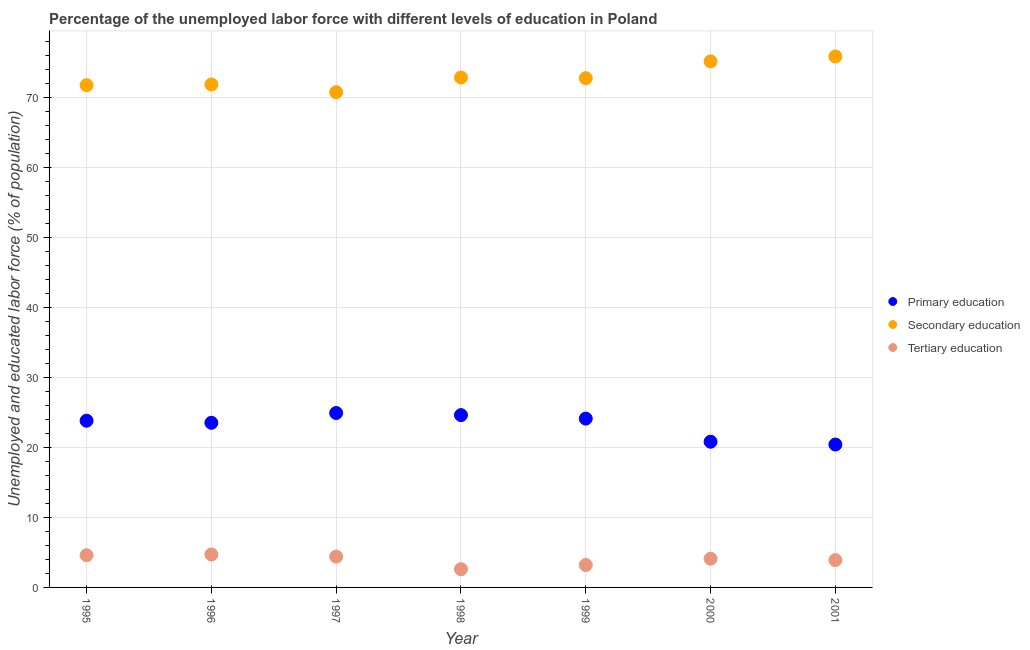Is the number of dotlines equal to the number of legend labels?
Your answer should be compact. Yes. What is the percentage of labor force who received primary education in 2000?
Your answer should be very brief. 20.8. Across all years, what is the maximum percentage of labor force who received primary education?
Provide a short and direct response. 24.9. Across all years, what is the minimum percentage of labor force who received tertiary education?
Give a very brief answer. 2.6. In which year was the percentage of labor force who received tertiary education minimum?
Your answer should be compact. 1998. What is the total percentage of labor force who received secondary education in the graph?
Provide a succinct answer. 510.6. What is the difference between the percentage of labor force who received primary education in 1996 and that in 2000?
Give a very brief answer. 2.7. What is the difference between the percentage of labor force who received tertiary education in 1996 and the percentage of labor force who received primary education in 1995?
Ensure brevity in your answer.  -19.1. What is the average percentage of labor force who received tertiary education per year?
Your response must be concise. 3.93. In the year 2001, what is the difference between the percentage of labor force who received secondary education and percentage of labor force who received tertiary education?
Offer a terse response. 71.9. In how many years, is the percentage of labor force who received tertiary education greater than 68 %?
Your answer should be compact. 0. What is the ratio of the percentage of labor force who received secondary education in 1997 to that in 2001?
Provide a short and direct response. 0.93. Is the percentage of labor force who received secondary education in 1996 less than that in 1999?
Your answer should be very brief. Yes. Is the difference between the percentage of labor force who received primary education in 1998 and 1999 greater than the difference between the percentage of labor force who received secondary education in 1998 and 1999?
Give a very brief answer. Yes. What is the difference between the highest and the second highest percentage of labor force who received secondary education?
Make the answer very short. 0.7. What is the difference between the highest and the lowest percentage of labor force who received tertiary education?
Your answer should be very brief. 2.1. In how many years, is the percentage of labor force who received secondary education greater than the average percentage of labor force who received secondary education taken over all years?
Your answer should be very brief. 2. Does the percentage of labor force who received tertiary education monotonically increase over the years?
Ensure brevity in your answer.  No. Is the percentage of labor force who received primary education strictly less than the percentage of labor force who received secondary education over the years?
Make the answer very short. Yes. How many dotlines are there?
Your answer should be very brief. 3. What is the difference between two consecutive major ticks on the Y-axis?
Make the answer very short. 10. Are the values on the major ticks of Y-axis written in scientific E-notation?
Give a very brief answer. No. Where does the legend appear in the graph?
Your answer should be very brief. Center right. What is the title of the graph?
Ensure brevity in your answer.  Percentage of the unemployed labor force with different levels of education in Poland. What is the label or title of the Y-axis?
Offer a terse response. Unemployed and educated labor force (% of population). What is the Unemployed and educated labor force (% of population) of Primary education in 1995?
Give a very brief answer. 23.8. What is the Unemployed and educated labor force (% of population) of Secondary education in 1995?
Keep it short and to the point. 71.7. What is the Unemployed and educated labor force (% of population) of Tertiary education in 1995?
Provide a succinct answer. 4.6. What is the Unemployed and educated labor force (% of population) of Secondary education in 1996?
Offer a very short reply. 71.8. What is the Unemployed and educated labor force (% of population) of Tertiary education in 1996?
Ensure brevity in your answer.  4.7. What is the Unemployed and educated labor force (% of population) of Primary education in 1997?
Provide a short and direct response. 24.9. What is the Unemployed and educated labor force (% of population) of Secondary education in 1997?
Make the answer very short. 70.7. What is the Unemployed and educated labor force (% of population) of Tertiary education in 1997?
Provide a short and direct response. 4.4. What is the Unemployed and educated labor force (% of population) in Primary education in 1998?
Your answer should be compact. 24.6. What is the Unemployed and educated labor force (% of population) in Secondary education in 1998?
Your response must be concise. 72.8. What is the Unemployed and educated labor force (% of population) in Tertiary education in 1998?
Give a very brief answer. 2.6. What is the Unemployed and educated labor force (% of population) of Primary education in 1999?
Keep it short and to the point. 24.1. What is the Unemployed and educated labor force (% of population) of Secondary education in 1999?
Your answer should be very brief. 72.7. What is the Unemployed and educated labor force (% of population) of Tertiary education in 1999?
Keep it short and to the point. 3.2. What is the Unemployed and educated labor force (% of population) of Primary education in 2000?
Your response must be concise. 20.8. What is the Unemployed and educated labor force (% of population) in Secondary education in 2000?
Make the answer very short. 75.1. What is the Unemployed and educated labor force (% of population) of Tertiary education in 2000?
Offer a very short reply. 4.1. What is the Unemployed and educated labor force (% of population) in Primary education in 2001?
Make the answer very short. 20.4. What is the Unemployed and educated labor force (% of population) in Secondary education in 2001?
Make the answer very short. 75.8. What is the Unemployed and educated labor force (% of population) of Tertiary education in 2001?
Your answer should be very brief. 3.9. Across all years, what is the maximum Unemployed and educated labor force (% of population) of Primary education?
Give a very brief answer. 24.9. Across all years, what is the maximum Unemployed and educated labor force (% of population) in Secondary education?
Give a very brief answer. 75.8. Across all years, what is the maximum Unemployed and educated labor force (% of population) in Tertiary education?
Make the answer very short. 4.7. Across all years, what is the minimum Unemployed and educated labor force (% of population) in Primary education?
Offer a terse response. 20.4. Across all years, what is the minimum Unemployed and educated labor force (% of population) of Secondary education?
Make the answer very short. 70.7. Across all years, what is the minimum Unemployed and educated labor force (% of population) of Tertiary education?
Your response must be concise. 2.6. What is the total Unemployed and educated labor force (% of population) of Primary education in the graph?
Offer a very short reply. 162.1. What is the total Unemployed and educated labor force (% of population) of Secondary education in the graph?
Your answer should be compact. 510.6. What is the total Unemployed and educated labor force (% of population) of Tertiary education in the graph?
Your answer should be very brief. 27.5. What is the difference between the Unemployed and educated labor force (% of population) in Secondary education in 1995 and that in 1996?
Your answer should be compact. -0.1. What is the difference between the Unemployed and educated labor force (% of population) in Tertiary education in 1995 and that in 1996?
Ensure brevity in your answer.  -0.1. What is the difference between the Unemployed and educated labor force (% of population) of Primary education in 1995 and that in 1997?
Keep it short and to the point. -1.1. What is the difference between the Unemployed and educated labor force (% of population) of Tertiary education in 1995 and that in 1997?
Give a very brief answer. 0.2. What is the difference between the Unemployed and educated labor force (% of population) in Tertiary education in 1995 and that in 1998?
Offer a very short reply. 2. What is the difference between the Unemployed and educated labor force (% of population) of Tertiary education in 1995 and that in 1999?
Offer a terse response. 1.4. What is the difference between the Unemployed and educated labor force (% of population) in Secondary education in 1995 and that in 2000?
Keep it short and to the point. -3.4. What is the difference between the Unemployed and educated labor force (% of population) of Tertiary education in 1995 and that in 2000?
Your response must be concise. 0.5. What is the difference between the Unemployed and educated labor force (% of population) in Secondary education in 1996 and that in 1997?
Offer a terse response. 1.1. What is the difference between the Unemployed and educated labor force (% of population) of Tertiary education in 1996 and that in 1997?
Ensure brevity in your answer.  0.3. What is the difference between the Unemployed and educated labor force (% of population) in Tertiary education in 1996 and that in 1998?
Offer a very short reply. 2.1. What is the difference between the Unemployed and educated labor force (% of population) of Secondary education in 1996 and that in 1999?
Your answer should be very brief. -0.9. What is the difference between the Unemployed and educated labor force (% of population) in Secondary education in 1996 and that in 2001?
Give a very brief answer. -4. What is the difference between the Unemployed and educated labor force (% of population) of Secondary education in 1997 and that in 1998?
Ensure brevity in your answer.  -2.1. What is the difference between the Unemployed and educated labor force (% of population) in Primary education in 1997 and that in 2000?
Provide a short and direct response. 4.1. What is the difference between the Unemployed and educated labor force (% of population) of Primary education in 1997 and that in 2001?
Provide a succinct answer. 4.5. What is the difference between the Unemployed and educated labor force (% of population) of Secondary education in 1997 and that in 2001?
Offer a terse response. -5.1. What is the difference between the Unemployed and educated labor force (% of population) in Secondary education in 1998 and that in 1999?
Offer a very short reply. 0.1. What is the difference between the Unemployed and educated labor force (% of population) in Tertiary education in 1998 and that in 1999?
Your response must be concise. -0.6. What is the difference between the Unemployed and educated labor force (% of population) in Primary education in 1998 and that in 2001?
Your answer should be compact. 4.2. What is the difference between the Unemployed and educated labor force (% of population) of Tertiary education in 1998 and that in 2001?
Make the answer very short. -1.3. What is the difference between the Unemployed and educated labor force (% of population) in Primary education in 1999 and that in 2000?
Offer a terse response. 3.3. What is the difference between the Unemployed and educated labor force (% of population) in Tertiary education in 1999 and that in 2000?
Give a very brief answer. -0.9. What is the difference between the Unemployed and educated labor force (% of population) of Primary education in 1999 and that in 2001?
Ensure brevity in your answer.  3.7. What is the difference between the Unemployed and educated labor force (% of population) of Tertiary education in 1999 and that in 2001?
Offer a terse response. -0.7. What is the difference between the Unemployed and educated labor force (% of population) of Tertiary education in 2000 and that in 2001?
Give a very brief answer. 0.2. What is the difference between the Unemployed and educated labor force (% of population) in Primary education in 1995 and the Unemployed and educated labor force (% of population) in Secondary education in 1996?
Your answer should be compact. -48. What is the difference between the Unemployed and educated labor force (% of population) in Secondary education in 1995 and the Unemployed and educated labor force (% of population) in Tertiary education in 1996?
Make the answer very short. 67. What is the difference between the Unemployed and educated labor force (% of population) of Primary education in 1995 and the Unemployed and educated labor force (% of population) of Secondary education in 1997?
Keep it short and to the point. -46.9. What is the difference between the Unemployed and educated labor force (% of population) of Primary education in 1995 and the Unemployed and educated labor force (% of population) of Tertiary education in 1997?
Make the answer very short. 19.4. What is the difference between the Unemployed and educated labor force (% of population) in Secondary education in 1995 and the Unemployed and educated labor force (% of population) in Tertiary education in 1997?
Offer a terse response. 67.3. What is the difference between the Unemployed and educated labor force (% of population) in Primary education in 1995 and the Unemployed and educated labor force (% of population) in Secondary education in 1998?
Offer a very short reply. -49. What is the difference between the Unemployed and educated labor force (% of population) of Primary education in 1995 and the Unemployed and educated labor force (% of population) of Tertiary education in 1998?
Ensure brevity in your answer.  21.2. What is the difference between the Unemployed and educated labor force (% of population) in Secondary education in 1995 and the Unemployed and educated labor force (% of population) in Tertiary education in 1998?
Provide a succinct answer. 69.1. What is the difference between the Unemployed and educated labor force (% of population) in Primary education in 1995 and the Unemployed and educated labor force (% of population) in Secondary education in 1999?
Give a very brief answer. -48.9. What is the difference between the Unemployed and educated labor force (% of population) in Primary education in 1995 and the Unemployed and educated labor force (% of population) in Tertiary education in 1999?
Keep it short and to the point. 20.6. What is the difference between the Unemployed and educated labor force (% of population) of Secondary education in 1995 and the Unemployed and educated labor force (% of population) of Tertiary education in 1999?
Offer a very short reply. 68.5. What is the difference between the Unemployed and educated labor force (% of population) of Primary education in 1995 and the Unemployed and educated labor force (% of population) of Secondary education in 2000?
Your answer should be compact. -51.3. What is the difference between the Unemployed and educated labor force (% of population) of Primary education in 1995 and the Unemployed and educated labor force (% of population) of Tertiary education in 2000?
Keep it short and to the point. 19.7. What is the difference between the Unemployed and educated labor force (% of population) of Secondary education in 1995 and the Unemployed and educated labor force (% of population) of Tertiary education in 2000?
Your answer should be very brief. 67.6. What is the difference between the Unemployed and educated labor force (% of population) of Primary education in 1995 and the Unemployed and educated labor force (% of population) of Secondary education in 2001?
Offer a terse response. -52. What is the difference between the Unemployed and educated labor force (% of population) in Secondary education in 1995 and the Unemployed and educated labor force (% of population) in Tertiary education in 2001?
Give a very brief answer. 67.8. What is the difference between the Unemployed and educated labor force (% of population) in Primary education in 1996 and the Unemployed and educated labor force (% of population) in Secondary education in 1997?
Provide a succinct answer. -47.2. What is the difference between the Unemployed and educated labor force (% of population) of Secondary education in 1996 and the Unemployed and educated labor force (% of population) of Tertiary education in 1997?
Make the answer very short. 67.4. What is the difference between the Unemployed and educated labor force (% of population) of Primary education in 1996 and the Unemployed and educated labor force (% of population) of Secondary education in 1998?
Offer a very short reply. -49.3. What is the difference between the Unemployed and educated labor force (% of population) in Primary education in 1996 and the Unemployed and educated labor force (% of population) in Tertiary education in 1998?
Give a very brief answer. 20.9. What is the difference between the Unemployed and educated labor force (% of population) of Secondary education in 1996 and the Unemployed and educated labor force (% of population) of Tertiary education in 1998?
Give a very brief answer. 69.2. What is the difference between the Unemployed and educated labor force (% of population) in Primary education in 1996 and the Unemployed and educated labor force (% of population) in Secondary education in 1999?
Your answer should be very brief. -49.2. What is the difference between the Unemployed and educated labor force (% of population) of Primary education in 1996 and the Unemployed and educated labor force (% of population) of Tertiary education in 1999?
Your answer should be compact. 20.3. What is the difference between the Unemployed and educated labor force (% of population) of Secondary education in 1996 and the Unemployed and educated labor force (% of population) of Tertiary education in 1999?
Your answer should be compact. 68.6. What is the difference between the Unemployed and educated labor force (% of population) of Primary education in 1996 and the Unemployed and educated labor force (% of population) of Secondary education in 2000?
Keep it short and to the point. -51.6. What is the difference between the Unemployed and educated labor force (% of population) of Primary education in 1996 and the Unemployed and educated labor force (% of population) of Tertiary education in 2000?
Your answer should be compact. 19.4. What is the difference between the Unemployed and educated labor force (% of population) in Secondary education in 1996 and the Unemployed and educated labor force (% of population) in Tertiary education in 2000?
Make the answer very short. 67.7. What is the difference between the Unemployed and educated labor force (% of population) of Primary education in 1996 and the Unemployed and educated labor force (% of population) of Secondary education in 2001?
Your answer should be very brief. -52.3. What is the difference between the Unemployed and educated labor force (% of population) of Primary education in 1996 and the Unemployed and educated labor force (% of population) of Tertiary education in 2001?
Ensure brevity in your answer.  19.6. What is the difference between the Unemployed and educated labor force (% of population) in Secondary education in 1996 and the Unemployed and educated labor force (% of population) in Tertiary education in 2001?
Give a very brief answer. 67.9. What is the difference between the Unemployed and educated labor force (% of population) of Primary education in 1997 and the Unemployed and educated labor force (% of population) of Secondary education in 1998?
Your response must be concise. -47.9. What is the difference between the Unemployed and educated labor force (% of population) of Primary education in 1997 and the Unemployed and educated labor force (% of population) of Tertiary education in 1998?
Ensure brevity in your answer.  22.3. What is the difference between the Unemployed and educated labor force (% of population) in Secondary education in 1997 and the Unemployed and educated labor force (% of population) in Tertiary education in 1998?
Ensure brevity in your answer.  68.1. What is the difference between the Unemployed and educated labor force (% of population) of Primary education in 1997 and the Unemployed and educated labor force (% of population) of Secondary education in 1999?
Provide a short and direct response. -47.8. What is the difference between the Unemployed and educated labor force (% of population) of Primary education in 1997 and the Unemployed and educated labor force (% of population) of Tertiary education in 1999?
Offer a terse response. 21.7. What is the difference between the Unemployed and educated labor force (% of population) of Secondary education in 1997 and the Unemployed and educated labor force (% of population) of Tertiary education in 1999?
Give a very brief answer. 67.5. What is the difference between the Unemployed and educated labor force (% of population) in Primary education in 1997 and the Unemployed and educated labor force (% of population) in Secondary education in 2000?
Offer a very short reply. -50.2. What is the difference between the Unemployed and educated labor force (% of population) in Primary education in 1997 and the Unemployed and educated labor force (% of population) in Tertiary education in 2000?
Your answer should be very brief. 20.8. What is the difference between the Unemployed and educated labor force (% of population) of Secondary education in 1997 and the Unemployed and educated labor force (% of population) of Tertiary education in 2000?
Ensure brevity in your answer.  66.6. What is the difference between the Unemployed and educated labor force (% of population) in Primary education in 1997 and the Unemployed and educated labor force (% of population) in Secondary education in 2001?
Keep it short and to the point. -50.9. What is the difference between the Unemployed and educated labor force (% of population) in Primary education in 1997 and the Unemployed and educated labor force (% of population) in Tertiary education in 2001?
Offer a terse response. 21. What is the difference between the Unemployed and educated labor force (% of population) in Secondary education in 1997 and the Unemployed and educated labor force (% of population) in Tertiary education in 2001?
Your answer should be compact. 66.8. What is the difference between the Unemployed and educated labor force (% of population) in Primary education in 1998 and the Unemployed and educated labor force (% of population) in Secondary education in 1999?
Give a very brief answer. -48.1. What is the difference between the Unemployed and educated labor force (% of population) in Primary education in 1998 and the Unemployed and educated labor force (% of population) in Tertiary education in 1999?
Make the answer very short. 21.4. What is the difference between the Unemployed and educated labor force (% of population) in Secondary education in 1998 and the Unemployed and educated labor force (% of population) in Tertiary education in 1999?
Offer a terse response. 69.6. What is the difference between the Unemployed and educated labor force (% of population) of Primary education in 1998 and the Unemployed and educated labor force (% of population) of Secondary education in 2000?
Your answer should be very brief. -50.5. What is the difference between the Unemployed and educated labor force (% of population) of Primary education in 1998 and the Unemployed and educated labor force (% of population) of Tertiary education in 2000?
Make the answer very short. 20.5. What is the difference between the Unemployed and educated labor force (% of population) of Secondary education in 1998 and the Unemployed and educated labor force (% of population) of Tertiary education in 2000?
Your answer should be compact. 68.7. What is the difference between the Unemployed and educated labor force (% of population) in Primary education in 1998 and the Unemployed and educated labor force (% of population) in Secondary education in 2001?
Your answer should be compact. -51.2. What is the difference between the Unemployed and educated labor force (% of population) in Primary education in 1998 and the Unemployed and educated labor force (% of population) in Tertiary education in 2001?
Make the answer very short. 20.7. What is the difference between the Unemployed and educated labor force (% of population) in Secondary education in 1998 and the Unemployed and educated labor force (% of population) in Tertiary education in 2001?
Give a very brief answer. 68.9. What is the difference between the Unemployed and educated labor force (% of population) in Primary education in 1999 and the Unemployed and educated labor force (% of population) in Secondary education in 2000?
Offer a terse response. -51. What is the difference between the Unemployed and educated labor force (% of population) of Primary education in 1999 and the Unemployed and educated labor force (% of population) of Tertiary education in 2000?
Your answer should be very brief. 20. What is the difference between the Unemployed and educated labor force (% of population) in Secondary education in 1999 and the Unemployed and educated labor force (% of population) in Tertiary education in 2000?
Your answer should be compact. 68.6. What is the difference between the Unemployed and educated labor force (% of population) of Primary education in 1999 and the Unemployed and educated labor force (% of population) of Secondary education in 2001?
Your answer should be compact. -51.7. What is the difference between the Unemployed and educated labor force (% of population) in Primary education in 1999 and the Unemployed and educated labor force (% of population) in Tertiary education in 2001?
Your answer should be compact. 20.2. What is the difference between the Unemployed and educated labor force (% of population) in Secondary education in 1999 and the Unemployed and educated labor force (% of population) in Tertiary education in 2001?
Provide a short and direct response. 68.8. What is the difference between the Unemployed and educated labor force (% of population) in Primary education in 2000 and the Unemployed and educated labor force (% of population) in Secondary education in 2001?
Your answer should be very brief. -55. What is the difference between the Unemployed and educated labor force (% of population) of Primary education in 2000 and the Unemployed and educated labor force (% of population) of Tertiary education in 2001?
Provide a short and direct response. 16.9. What is the difference between the Unemployed and educated labor force (% of population) of Secondary education in 2000 and the Unemployed and educated labor force (% of population) of Tertiary education in 2001?
Your response must be concise. 71.2. What is the average Unemployed and educated labor force (% of population) of Primary education per year?
Make the answer very short. 23.16. What is the average Unemployed and educated labor force (% of population) of Secondary education per year?
Offer a very short reply. 72.94. What is the average Unemployed and educated labor force (% of population) in Tertiary education per year?
Your answer should be compact. 3.93. In the year 1995, what is the difference between the Unemployed and educated labor force (% of population) in Primary education and Unemployed and educated labor force (% of population) in Secondary education?
Offer a very short reply. -47.9. In the year 1995, what is the difference between the Unemployed and educated labor force (% of population) in Primary education and Unemployed and educated labor force (% of population) in Tertiary education?
Offer a terse response. 19.2. In the year 1995, what is the difference between the Unemployed and educated labor force (% of population) in Secondary education and Unemployed and educated labor force (% of population) in Tertiary education?
Provide a succinct answer. 67.1. In the year 1996, what is the difference between the Unemployed and educated labor force (% of population) in Primary education and Unemployed and educated labor force (% of population) in Secondary education?
Make the answer very short. -48.3. In the year 1996, what is the difference between the Unemployed and educated labor force (% of population) in Secondary education and Unemployed and educated labor force (% of population) in Tertiary education?
Keep it short and to the point. 67.1. In the year 1997, what is the difference between the Unemployed and educated labor force (% of population) in Primary education and Unemployed and educated labor force (% of population) in Secondary education?
Ensure brevity in your answer.  -45.8. In the year 1997, what is the difference between the Unemployed and educated labor force (% of population) in Secondary education and Unemployed and educated labor force (% of population) in Tertiary education?
Your response must be concise. 66.3. In the year 1998, what is the difference between the Unemployed and educated labor force (% of population) in Primary education and Unemployed and educated labor force (% of population) in Secondary education?
Provide a short and direct response. -48.2. In the year 1998, what is the difference between the Unemployed and educated labor force (% of population) in Primary education and Unemployed and educated labor force (% of population) in Tertiary education?
Provide a short and direct response. 22. In the year 1998, what is the difference between the Unemployed and educated labor force (% of population) in Secondary education and Unemployed and educated labor force (% of population) in Tertiary education?
Your answer should be compact. 70.2. In the year 1999, what is the difference between the Unemployed and educated labor force (% of population) in Primary education and Unemployed and educated labor force (% of population) in Secondary education?
Provide a short and direct response. -48.6. In the year 1999, what is the difference between the Unemployed and educated labor force (% of population) in Primary education and Unemployed and educated labor force (% of population) in Tertiary education?
Offer a terse response. 20.9. In the year 1999, what is the difference between the Unemployed and educated labor force (% of population) in Secondary education and Unemployed and educated labor force (% of population) in Tertiary education?
Provide a succinct answer. 69.5. In the year 2000, what is the difference between the Unemployed and educated labor force (% of population) in Primary education and Unemployed and educated labor force (% of population) in Secondary education?
Offer a very short reply. -54.3. In the year 2000, what is the difference between the Unemployed and educated labor force (% of population) of Secondary education and Unemployed and educated labor force (% of population) of Tertiary education?
Your response must be concise. 71. In the year 2001, what is the difference between the Unemployed and educated labor force (% of population) of Primary education and Unemployed and educated labor force (% of population) of Secondary education?
Offer a very short reply. -55.4. In the year 2001, what is the difference between the Unemployed and educated labor force (% of population) of Primary education and Unemployed and educated labor force (% of population) of Tertiary education?
Provide a succinct answer. 16.5. In the year 2001, what is the difference between the Unemployed and educated labor force (% of population) in Secondary education and Unemployed and educated labor force (% of population) in Tertiary education?
Your answer should be compact. 71.9. What is the ratio of the Unemployed and educated labor force (% of population) of Primary education in 1995 to that in 1996?
Provide a succinct answer. 1.01. What is the ratio of the Unemployed and educated labor force (% of population) of Tertiary education in 1995 to that in 1996?
Provide a short and direct response. 0.98. What is the ratio of the Unemployed and educated labor force (% of population) in Primary education in 1995 to that in 1997?
Keep it short and to the point. 0.96. What is the ratio of the Unemployed and educated labor force (% of population) of Secondary education in 1995 to that in 1997?
Keep it short and to the point. 1.01. What is the ratio of the Unemployed and educated labor force (% of population) in Tertiary education in 1995 to that in 1997?
Make the answer very short. 1.05. What is the ratio of the Unemployed and educated labor force (% of population) in Primary education in 1995 to that in 1998?
Provide a short and direct response. 0.97. What is the ratio of the Unemployed and educated labor force (% of population) of Secondary education in 1995 to that in 1998?
Keep it short and to the point. 0.98. What is the ratio of the Unemployed and educated labor force (% of population) in Tertiary education in 1995 to that in 1998?
Your answer should be very brief. 1.77. What is the ratio of the Unemployed and educated labor force (% of population) of Primary education in 1995 to that in 1999?
Provide a short and direct response. 0.99. What is the ratio of the Unemployed and educated labor force (% of population) in Secondary education in 1995 to that in 1999?
Offer a terse response. 0.99. What is the ratio of the Unemployed and educated labor force (% of population) in Tertiary education in 1995 to that in 1999?
Offer a very short reply. 1.44. What is the ratio of the Unemployed and educated labor force (% of population) in Primary education in 1995 to that in 2000?
Make the answer very short. 1.14. What is the ratio of the Unemployed and educated labor force (% of population) in Secondary education in 1995 to that in 2000?
Offer a terse response. 0.95. What is the ratio of the Unemployed and educated labor force (% of population) of Tertiary education in 1995 to that in 2000?
Provide a short and direct response. 1.12. What is the ratio of the Unemployed and educated labor force (% of population) of Secondary education in 1995 to that in 2001?
Offer a terse response. 0.95. What is the ratio of the Unemployed and educated labor force (% of population) of Tertiary education in 1995 to that in 2001?
Your response must be concise. 1.18. What is the ratio of the Unemployed and educated labor force (% of population) of Primary education in 1996 to that in 1997?
Ensure brevity in your answer.  0.94. What is the ratio of the Unemployed and educated labor force (% of population) in Secondary education in 1996 to that in 1997?
Keep it short and to the point. 1.02. What is the ratio of the Unemployed and educated labor force (% of population) in Tertiary education in 1996 to that in 1997?
Provide a succinct answer. 1.07. What is the ratio of the Unemployed and educated labor force (% of population) in Primary education in 1996 to that in 1998?
Offer a terse response. 0.96. What is the ratio of the Unemployed and educated labor force (% of population) in Secondary education in 1996 to that in 1998?
Keep it short and to the point. 0.99. What is the ratio of the Unemployed and educated labor force (% of population) of Tertiary education in 1996 to that in 1998?
Keep it short and to the point. 1.81. What is the ratio of the Unemployed and educated labor force (% of population) of Primary education in 1996 to that in 1999?
Ensure brevity in your answer.  0.98. What is the ratio of the Unemployed and educated labor force (% of population) of Secondary education in 1996 to that in 1999?
Your response must be concise. 0.99. What is the ratio of the Unemployed and educated labor force (% of population) of Tertiary education in 1996 to that in 1999?
Give a very brief answer. 1.47. What is the ratio of the Unemployed and educated labor force (% of population) in Primary education in 1996 to that in 2000?
Give a very brief answer. 1.13. What is the ratio of the Unemployed and educated labor force (% of population) of Secondary education in 1996 to that in 2000?
Provide a succinct answer. 0.96. What is the ratio of the Unemployed and educated labor force (% of population) in Tertiary education in 1996 to that in 2000?
Provide a succinct answer. 1.15. What is the ratio of the Unemployed and educated labor force (% of population) of Primary education in 1996 to that in 2001?
Offer a very short reply. 1.15. What is the ratio of the Unemployed and educated labor force (% of population) in Secondary education in 1996 to that in 2001?
Give a very brief answer. 0.95. What is the ratio of the Unemployed and educated labor force (% of population) in Tertiary education in 1996 to that in 2001?
Make the answer very short. 1.21. What is the ratio of the Unemployed and educated labor force (% of population) of Primary education in 1997 to that in 1998?
Keep it short and to the point. 1.01. What is the ratio of the Unemployed and educated labor force (% of population) in Secondary education in 1997 to that in 1998?
Ensure brevity in your answer.  0.97. What is the ratio of the Unemployed and educated labor force (% of population) in Tertiary education in 1997 to that in 1998?
Keep it short and to the point. 1.69. What is the ratio of the Unemployed and educated labor force (% of population) of Primary education in 1997 to that in 1999?
Make the answer very short. 1.03. What is the ratio of the Unemployed and educated labor force (% of population) of Secondary education in 1997 to that in 1999?
Provide a succinct answer. 0.97. What is the ratio of the Unemployed and educated labor force (% of population) of Tertiary education in 1997 to that in 1999?
Give a very brief answer. 1.38. What is the ratio of the Unemployed and educated labor force (% of population) in Primary education in 1997 to that in 2000?
Your response must be concise. 1.2. What is the ratio of the Unemployed and educated labor force (% of population) in Secondary education in 1997 to that in 2000?
Ensure brevity in your answer.  0.94. What is the ratio of the Unemployed and educated labor force (% of population) in Tertiary education in 1997 to that in 2000?
Offer a very short reply. 1.07. What is the ratio of the Unemployed and educated labor force (% of population) of Primary education in 1997 to that in 2001?
Your answer should be very brief. 1.22. What is the ratio of the Unemployed and educated labor force (% of population) in Secondary education in 1997 to that in 2001?
Offer a terse response. 0.93. What is the ratio of the Unemployed and educated labor force (% of population) of Tertiary education in 1997 to that in 2001?
Give a very brief answer. 1.13. What is the ratio of the Unemployed and educated labor force (% of population) in Primary education in 1998 to that in 1999?
Make the answer very short. 1.02. What is the ratio of the Unemployed and educated labor force (% of population) in Secondary education in 1998 to that in 1999?
Make the answer very short. 1. What is the ratio of the Unemployed and educated labor force (% of population) in Tertiary education in 1998 to that in 1999?
Your answer should be compact. 0.81. What is the ratio of the Unemployed and educated labor force (% of population) in Primary education in 1998 to that in 2000?
Ensure brevity in your answer.  1.18. What is the ratio of the Unemployed and educated labor force (% of population) of Secondary education in 1998 to that in 2000?
Your response must be concise. 0.97. What is the ratio of the Unemployed and educated labor force (% of population) of Tertiary education in 1998 to that in 2000?
Your response must be concise. 0.63. What is the ratio of the Unemployed and educated labor force (% of population) in Primary education in 1998 to that in 2001?
Offer a very short reply. 1.21. What is the ratio of the Unemployed and educated labor force (% of population) in Secondary education in 1998 to that in 2001?
Your answer should be very brief. 0.96. What is the ratio of the Unemployed and educated labor force (% of population) in Primary education in 1999 to that in 2000?
Your response must be concise. 1.16. What is the ratio of the Unemployed and educated labor force (% of population) of Secondary education in 1999 to that in 2000?
Provide a short and direct response. 0.97. What is the ratio of the Unemployed and educated labor force (% of population) of Tertiary education in 1999 to that in 2000?
Offer a very short reply. 0.78. What is the ratio of the Unemployed and educated labor force (% of population) in Primary education in 1999 to that in 2001?
Give a very brief answer. 1.18. What is the ratio of the Unemployed and educated labor force (% of population) of Secondary education in 1999 to that in 2001?
Offer a very short reply. 0.96. What is the ratio of the Unemployed and educated labor force (% of population) of Tertiary education in 1999 to that in 2001?
Provide a succinct answer. 0.82. What is the ratio of the Unemployed and educated labor force (% of population) in Primary education in 2000 to that in 2001?
Ensure brevity in your answer.  1.02. What is the ratio of the Unemployed and educated labor force (% of population) in Tertiary education in 2000 to that in 2001?
Offer a very short reply. 1.05. What is the difference between the highest and the second highest Unemployed and educated labor force (% of population) in Primary education?
Keep it short and to the point. 0.3. What is the difference between the highest and the second highest Unemployed and educated labor force (% of population) in Secondary education?
Your answer should be compact. 0.7. What is the difference between the highest and the second highest Unemployed and educated labor force (% of population) in Tertiary education?
Your answer should be compact. 0.1. What is the difference between the highest and the lowest Unemployed and educated labor force (% of population) of Primary education?
Ensure brevity in your answer.  4.5. What is the difference between the highest and the lowest Unemployed and educated labor force (% of population) of Secondary education?
Ensure brevity in your answer.  5.1. What is the difference between the highest and the lowest Unemployed and educated labor force (% of population) in Tertiary education?
Make the answer very short. 2.1. 